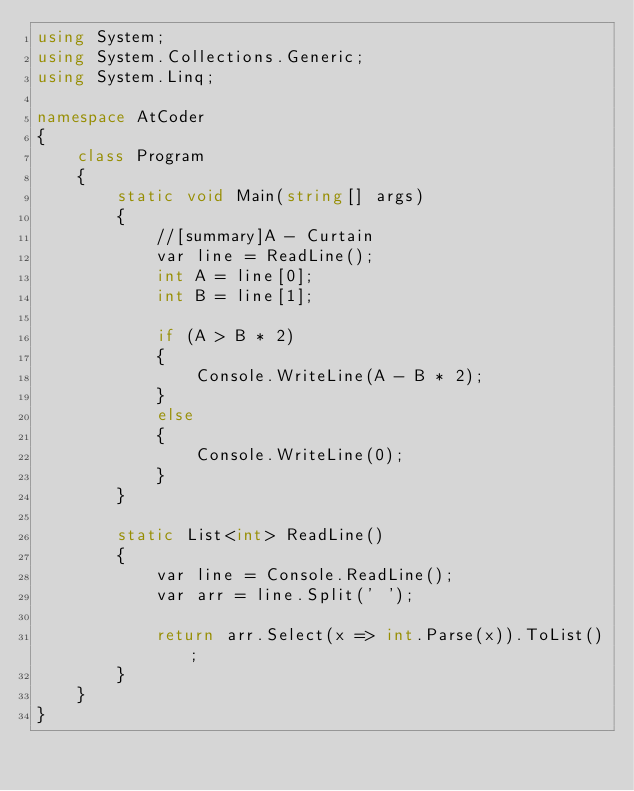Convert code to text. <code><loc_0><loc_0><loc_500><loc_500><_C#_>using System;
using System.Collections.Generic;
using System.Linq;

namespace AtCoder
{
    class Program
    {
        static void Main(string[] args)
        {
            //[summary]A - Curtain
            var line = ReadLine();
            int A = line[0];
            int B = line[1];

            if (A > B * 2)
            {
                Console.WriteLine(A - B * 2);
            }
            else
            {
                Console.WriteLine(0);
            }
        }

        static List<int> ReadLine()
        {
            var line = Console.ReadLine();
            var arr = line.Split(' ');

            return arr.Select(x => int.Parse(x)).ToList();
        }
    }
}</code> 